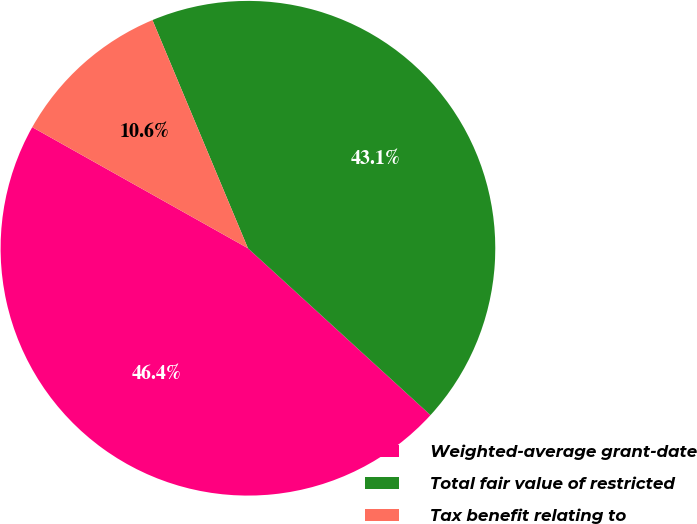Convert chart. <chart><loc_0><loc_0><loc_500><loc_500><pie_chart><fcel>Weighted-average grant-date<fcel>Total fair value of restricted<fcel>Tax benefit relating to<nl><fcel>46.35%<fcel>43.09%<fcel>10.55%<nl></chart> 